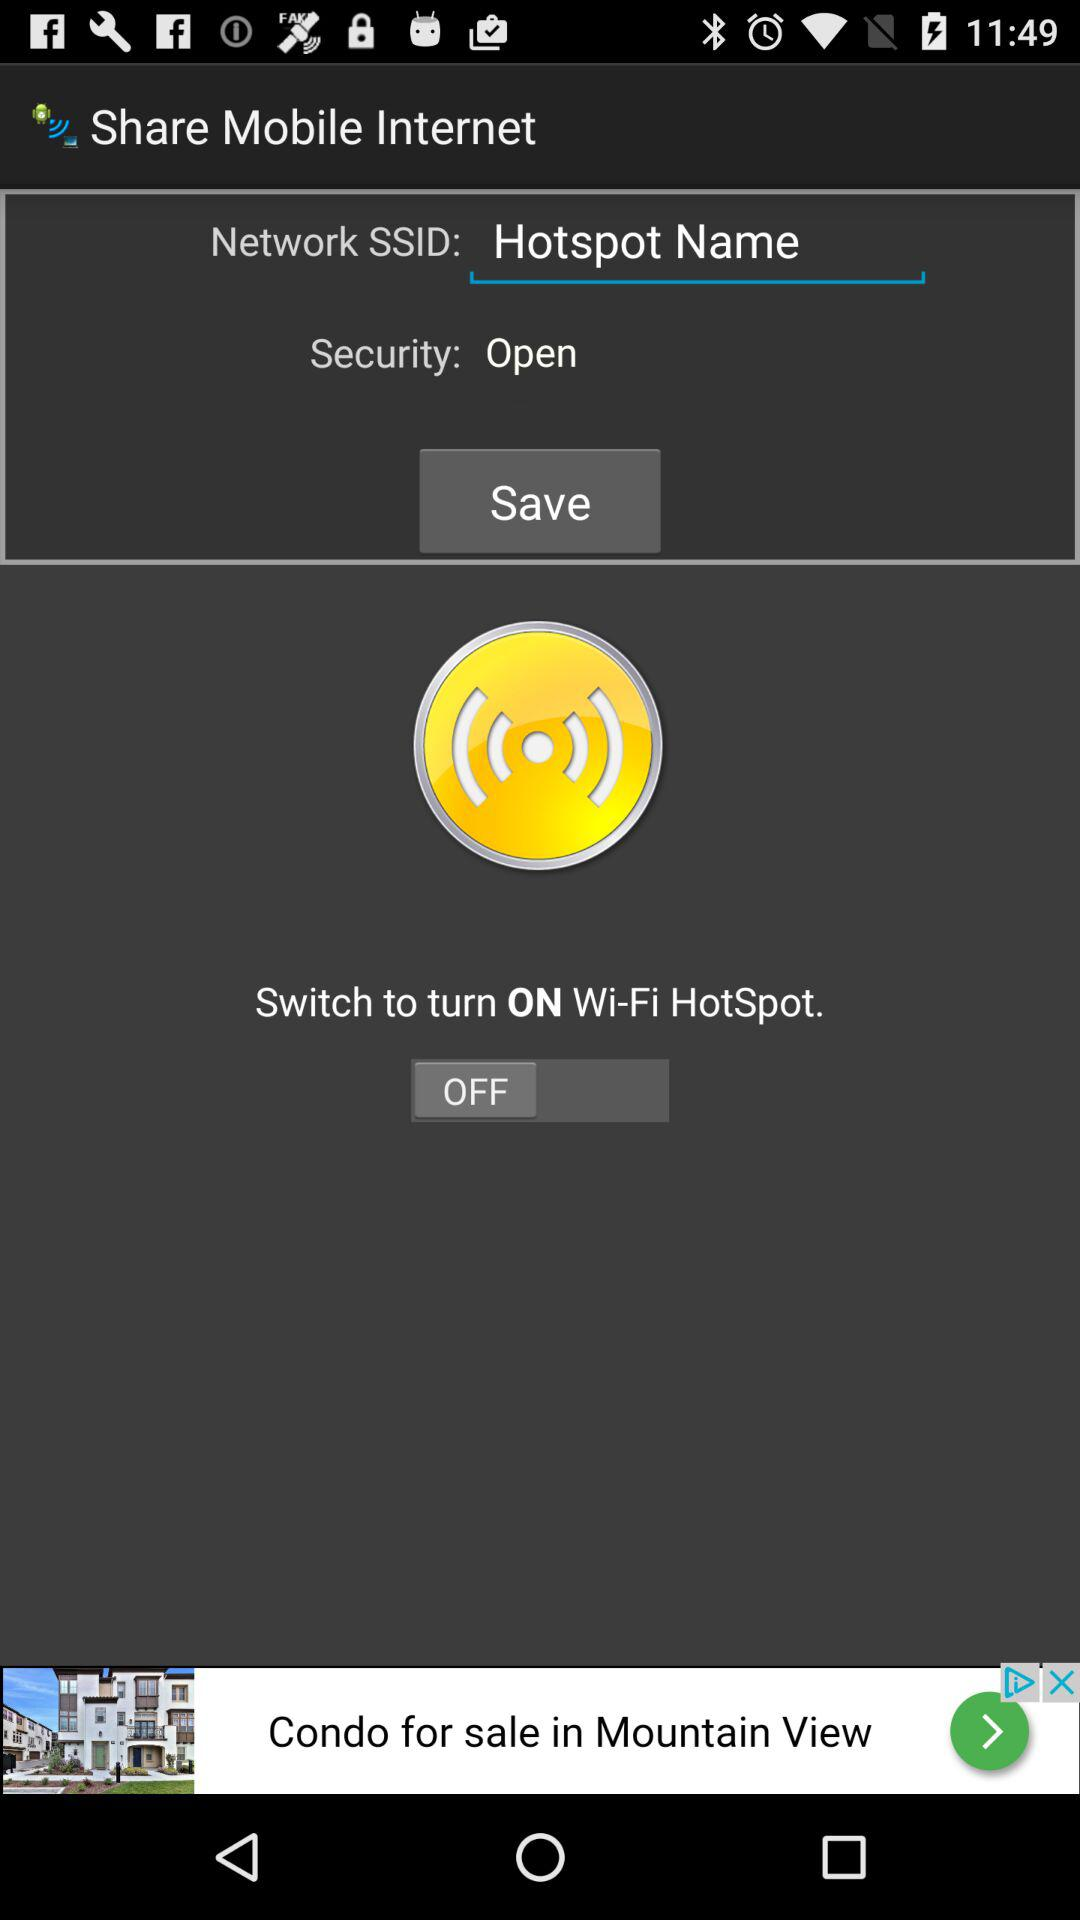What is the status of the "Wi-Fi HotSpot"? The status is "off". 